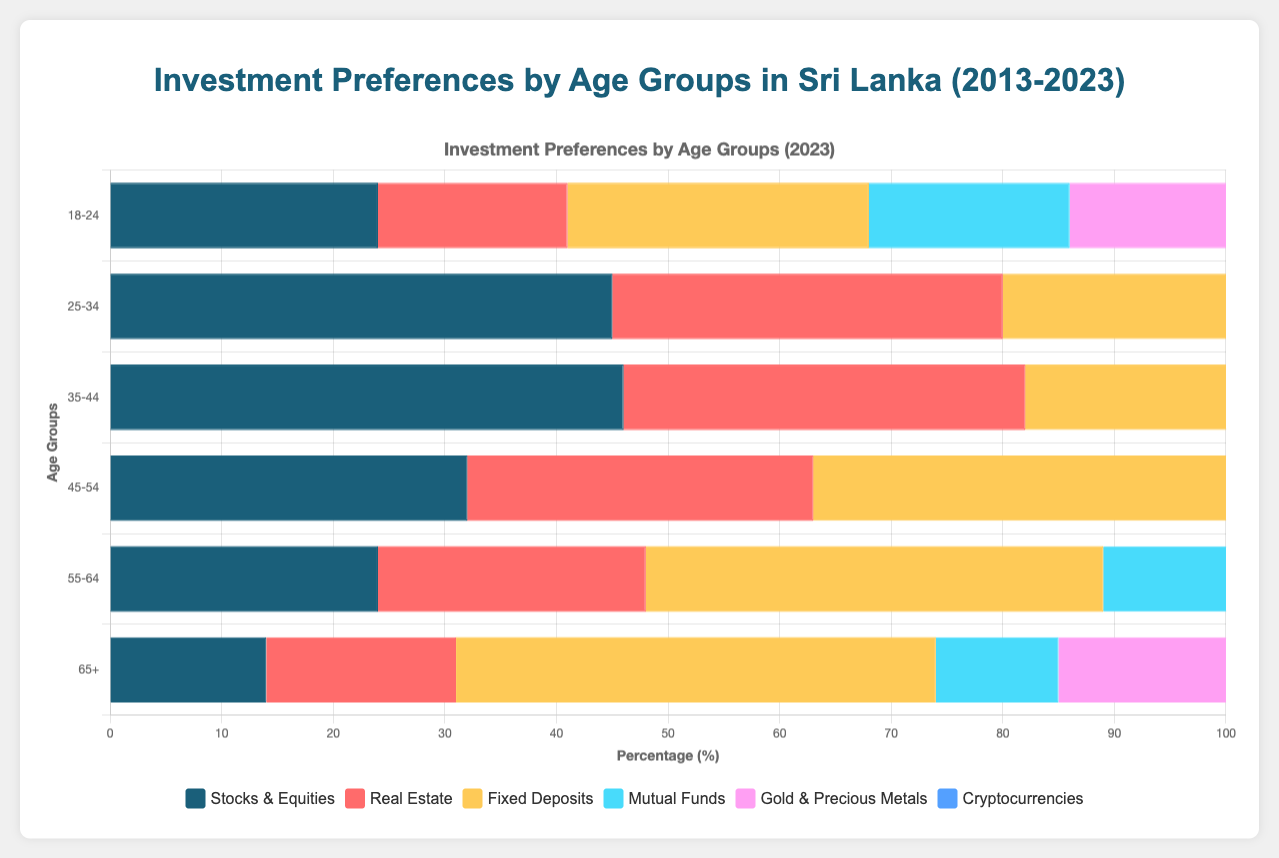Which age group has the highest preference for Crypto in 2023? By visually examining the length of the horizontal bars for Cryptocurrencies in 2023, the 18-24 age group has the longest bar, indicating it has the highest preference.
Answer: 18-24 What is the difference in preference for Fixed Deposits between the 25-34 and 65+ age groups in 2023? The 25-34 age group shows a bar for Fixed Deposits close to 45%, while the 65+ age group shows about 43%. The difference is 45 - 43 = 2.
Answer: 2 Which investment type is most preferred by the 55-64 age group in 2023? By comparing the lengths of horizontal bars for the 55-64 age group, Fixed Deposits have the longest bar, indicating the highest preference.
Answer: Fixed Deposits Between Stocks & Equities and Real Estate, which is more preferred by the 35-44 age group in 2023? By comparing the horizontal bars for the 35-44 age group, Stocks & Equities have a longer bar compared to Real Estate, indicating a higher preference.
Answer: Stocks & Equities What is the combined preference for Mutual Funds for the 18-24 age group in 2013 and 2023? For the 18-24 age group, the preference for Mutual Funds in 2013 is 4% and in 2023 is 18%. Adding these values results in 4 + 18 = 22.
Answer: 22 Which investment type showed the most dramatic increase in preference for the 18-24 age group from 2013 to 2023? For the 18-24 age group, Cryptocurrencies increased from 1% in 2013 to 16% in 2023, making the increase 16 - 1 = 15, which is the highest increase compared to all types.
Answer: Cryptocurrencies For the 25-34 age group, which investment type showed a greater preference in 2023: Gold & Precious Metals or Fixed Deposits? By comparing the lengths of the horizontal bars in 2023 for the 25-34 age group, Fixed Deposits have a longer bar compared to Gold & Precious Metals.
Answer: Fixed Deposits What was the average preference for Real Estate across all age groups in 2023? Adding the preference percentages for Real Estate across all age groups in 2023 (17, 35, 36, 31, 24, 17) gives 160. Dividing by the number of age groups (6) results in 160 / 6 ≈ 26.67.
Answer: 26.67 Which age group shows the least preference for Mutual Funds in 2023? By examining the Mutual Funds bar across all age groups, the 65+ age group has the shortest bar, indicating the least preference.
Answer: 65+ 